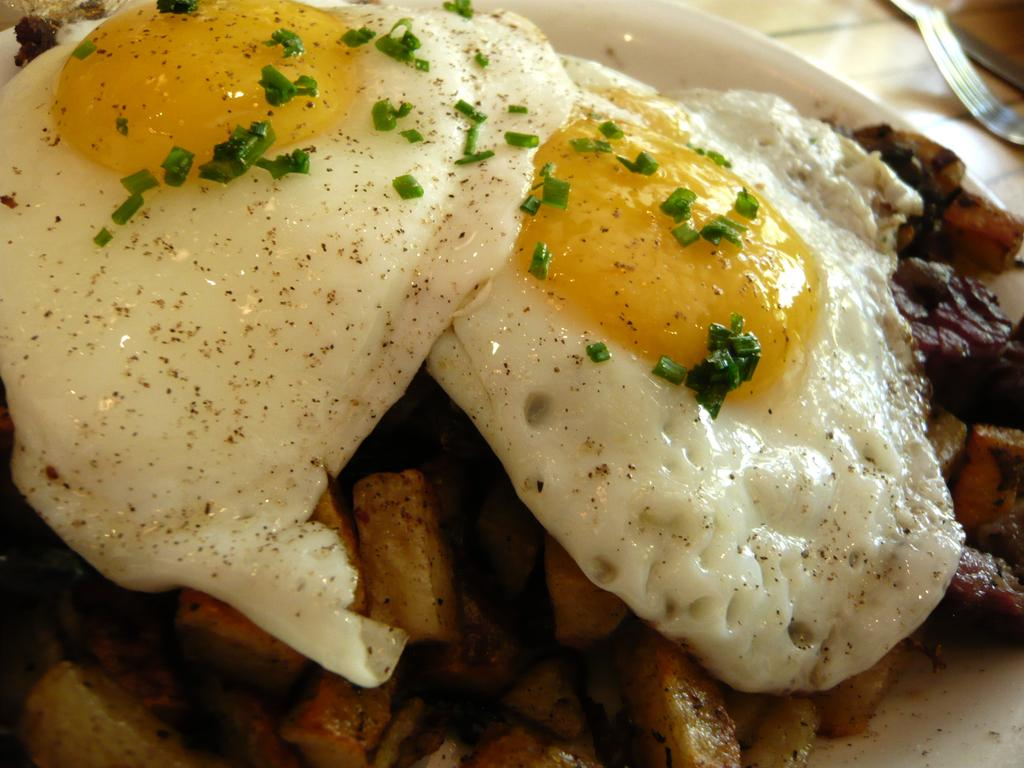Where was the image taken? The image is taken indoors. What piece of furniture is present in the image? There is a table in the image. What utensil can be seen on the table? There is a fork on the table. What is on the plate that is on the table? The plate contains an omelette and fries. What type of dog can be seen eating the omelette in the image? There is no dog present in the image, and the omelette is not being eaten by any animal. How does the omelette taste in the image? The image does not provide any information about the taste of the omelette. 